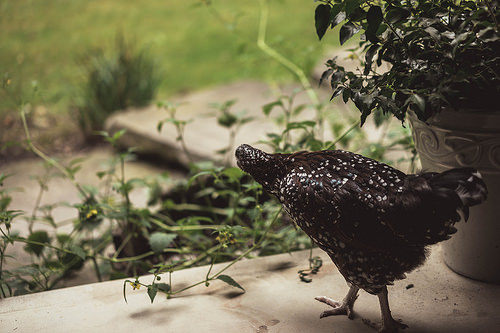<image>
Is the weed behind the dead flowers? Yes. From this viewpoint, the weed is positioned behind the dead flowers, with the dead flowers partially or fully occluding the weed. Where is the bird in relation to the pot? Is it in the pot? No. The bird is not contained within the pot. These objects have a different spatial relationship. 